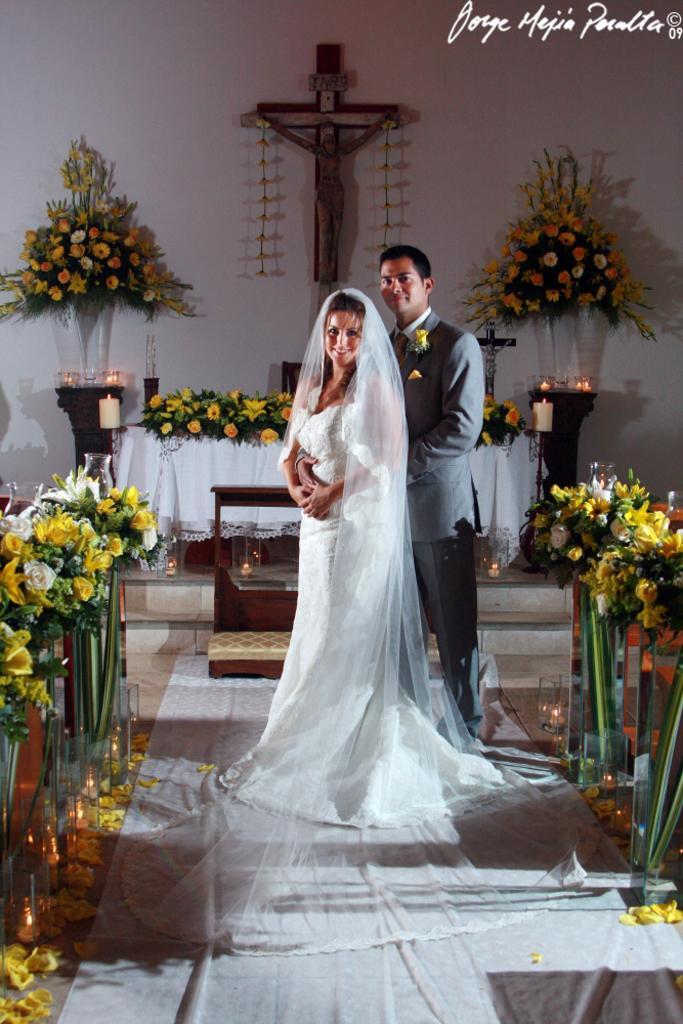How would you summarize this image in a sentence or two? In this image we can see a man and a woman standing on the cloth and they are smiling. Here we can see flower bouquets, tablecloth, and candles. In the background we can see wall and a statue. At the top of the image we can see something is written on it. 